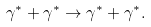Convert formula to latex. <formula><loc_0><loc_0><loc_500><loc_500>\gamma ^ { * } + \gamma ^ { * } \rightarrow \gamma ^ { * } + \gamma ^ { * } .</formula> 